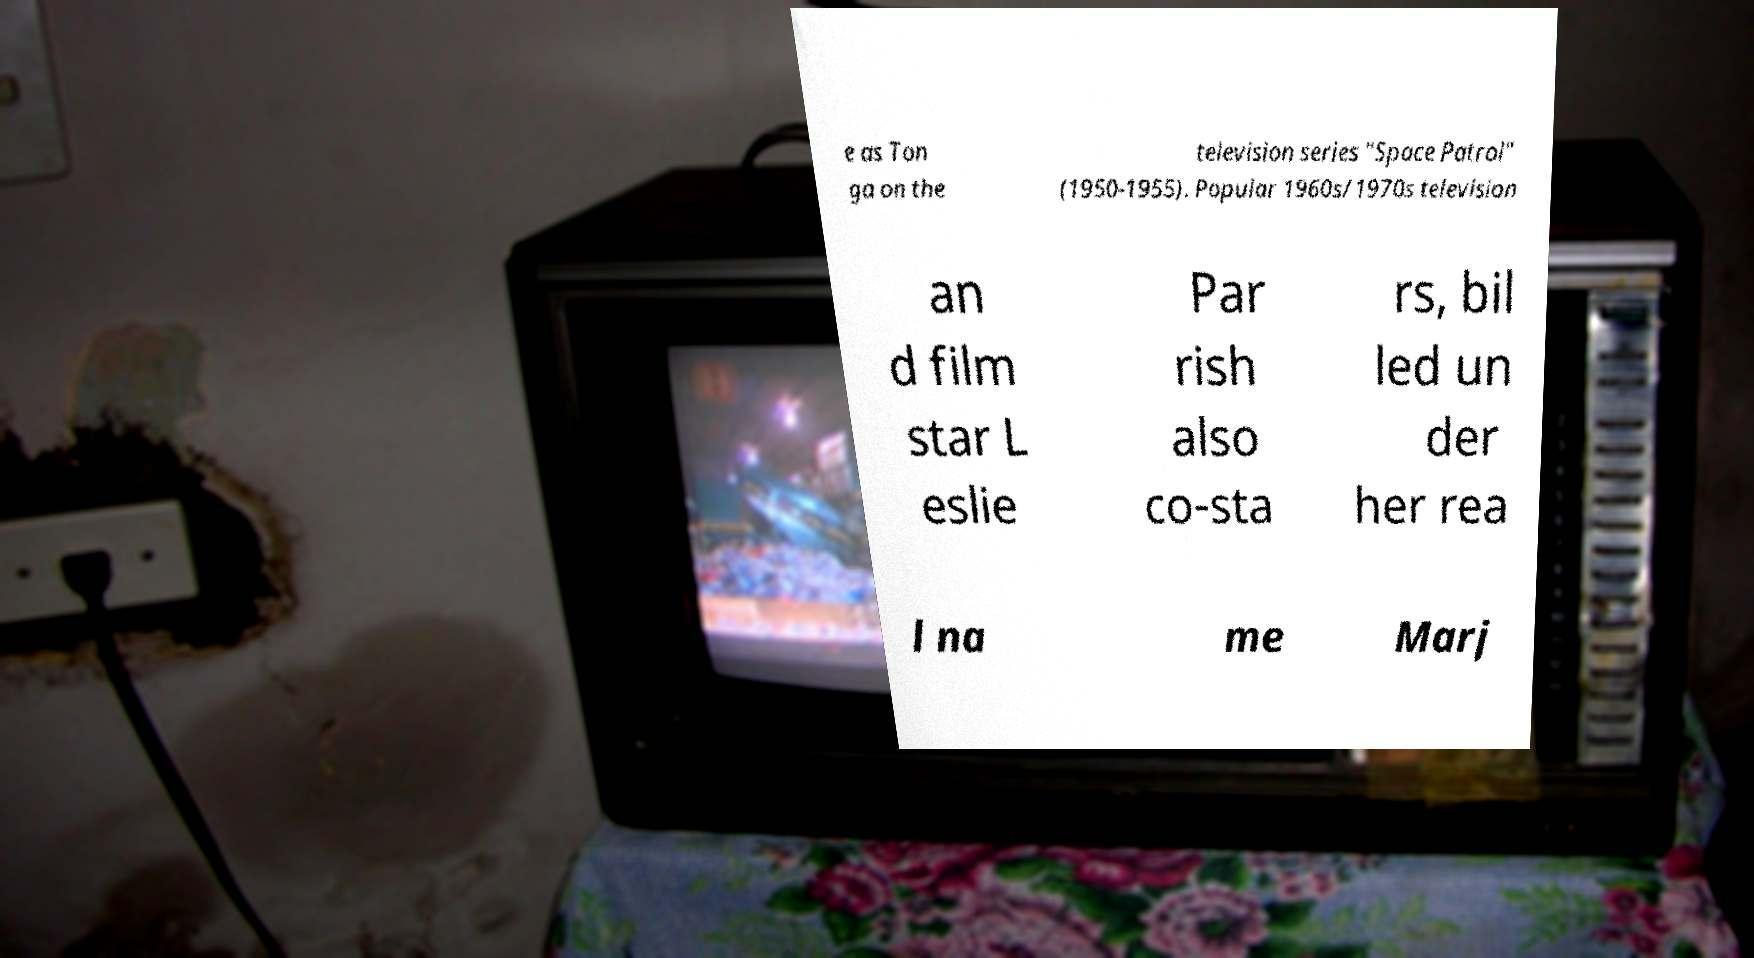Please read and relay the text visible in this image. What does it say? e as Ton ga on the television series "Space Patrol" (1950-1955). Popular 1960s/1970s television an d film star L eslie Par rish also co-sta rs, bil led un der her rea l na me Marj 